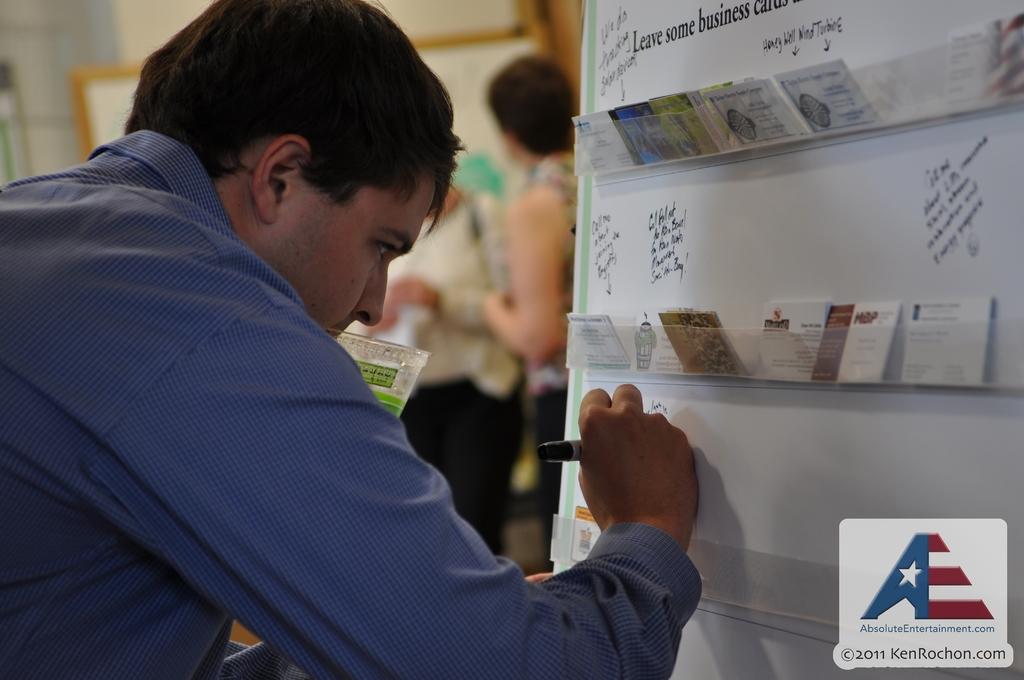What year is this image from in the bottom right corner?
Give a very brief answer. 2011. 